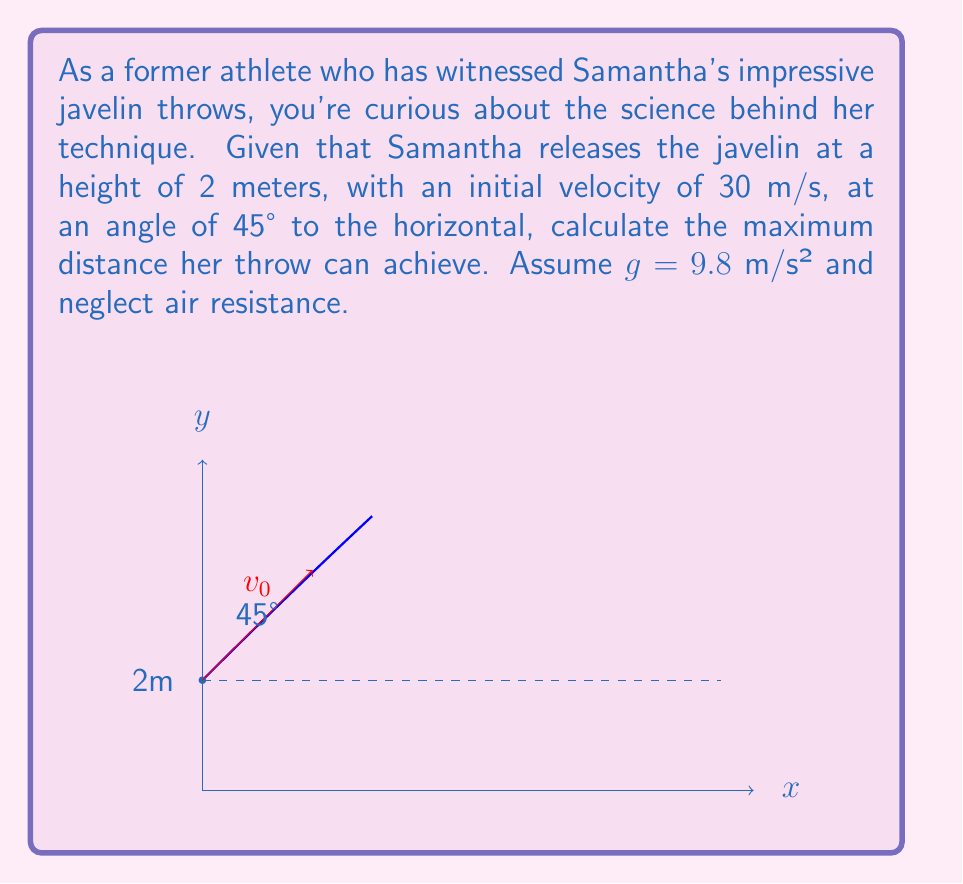Can you answer this question? Let's approach this step-by-step:

1) The motion of the javelin can be split into horizontal and vertical components.

2) Horizontal motion:
   - Constant velocity: $v_x = v_0 \cos \theta = 30 \cos 45° = 30 \cdot \frac{\sqrt{2}}{2} \approx 21.21$ m/s
   - Distance: $x = v_x t$

3) Vertical motion:
   - Initial velocity: $v_y = v_0 \sin \theta = 30 \sin 45° = 30 \cdot \frac{\sqrt{2}}{2} \approx 21.21$ m/s
   - Position: $y = h_0 + v_y t - \frac{1}{2}gt^2$, where $h_0 = 2$ m

4) The javelin reaches the ground when $y = 0$. We can find this time:
   $0 = 2 + 21.21t - 4.9t^2$
   $4.9t^2 - 21.21t - 2 = 0$

5) Solving this quadratic equation:
   $t = \frac{21.21 + \sqrt{21.21^2 + 4(4.9)(2)}}{2(4.9)} \approx 4.37$ s

6) Now we can find the horizontal distance:
   $x = v_x t = 21.21 \cdot 4.37 \approx 92.69$ m

7) We can verify this using the range formula for projectile motion from an elevated position:
   $$R = v_0 \cos \theta \left(\frac{v_0 \sin \theta + \sqrt{(v_0 \sin \theta)^2 + 2gh_0}}{g}\right)$$
   
   Plugging in our values:
   $$R = 30 \cos 45° \left(\frac{30 \sin 45° + \sqrt{(30 \sin 45°)^2 + 2(9.8)(2)}}{9.8}\right) \approx 92.69 \text{ m}$$
Answer: 92.69 m 